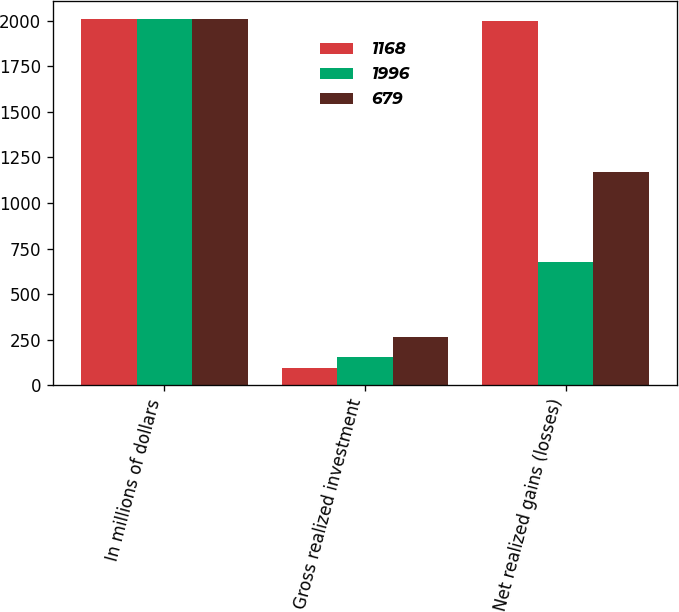Convert chart. <chart><loc_0><loc_0><loc_500><loc_500><stacked_bar_chart><ecel><fcel>In millions of dollars<fcel>Gross realized investment<fcel>Net realized gains (losses)<nl><fcel>1168<fcel>2009<fcel>94<fcel>1996<nl><fcel>1996<fcel>2008<fcel>158<fcel>679<nl><fcel>679<fcel>2007<fcel>267<fcel>1168<nl></chart> 